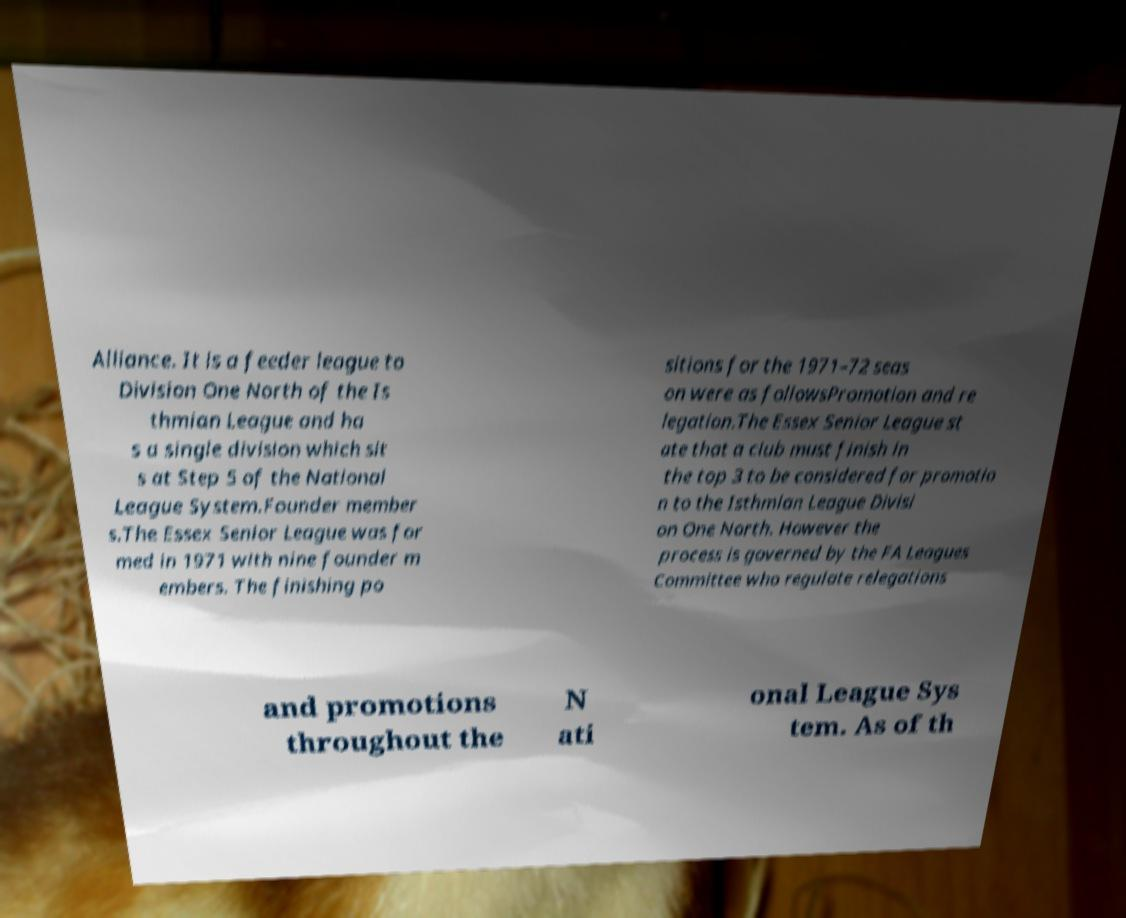For documentation purposes, I need the text within this image transcribed. Could you provide that? Alliance. It is a feeder league to Division One North of the Is thmian League and ha s a single division which sit s at Step 5 of the National League System.Founder member s.The Essex Senior League was for med in 1971 with nine founder m embers. The finishing po sitions for the 1971–72 seas on were as followsPromotion and re legation.The Essex Senior League st ate that a club must finish in the top 3 to be considered for promotio n to the Isthmian League Divisi on One North. However the process is governed by the FA Leagues Committee who regulate relegations and promotions throughout the N ati onal League Sys tem. As of th 